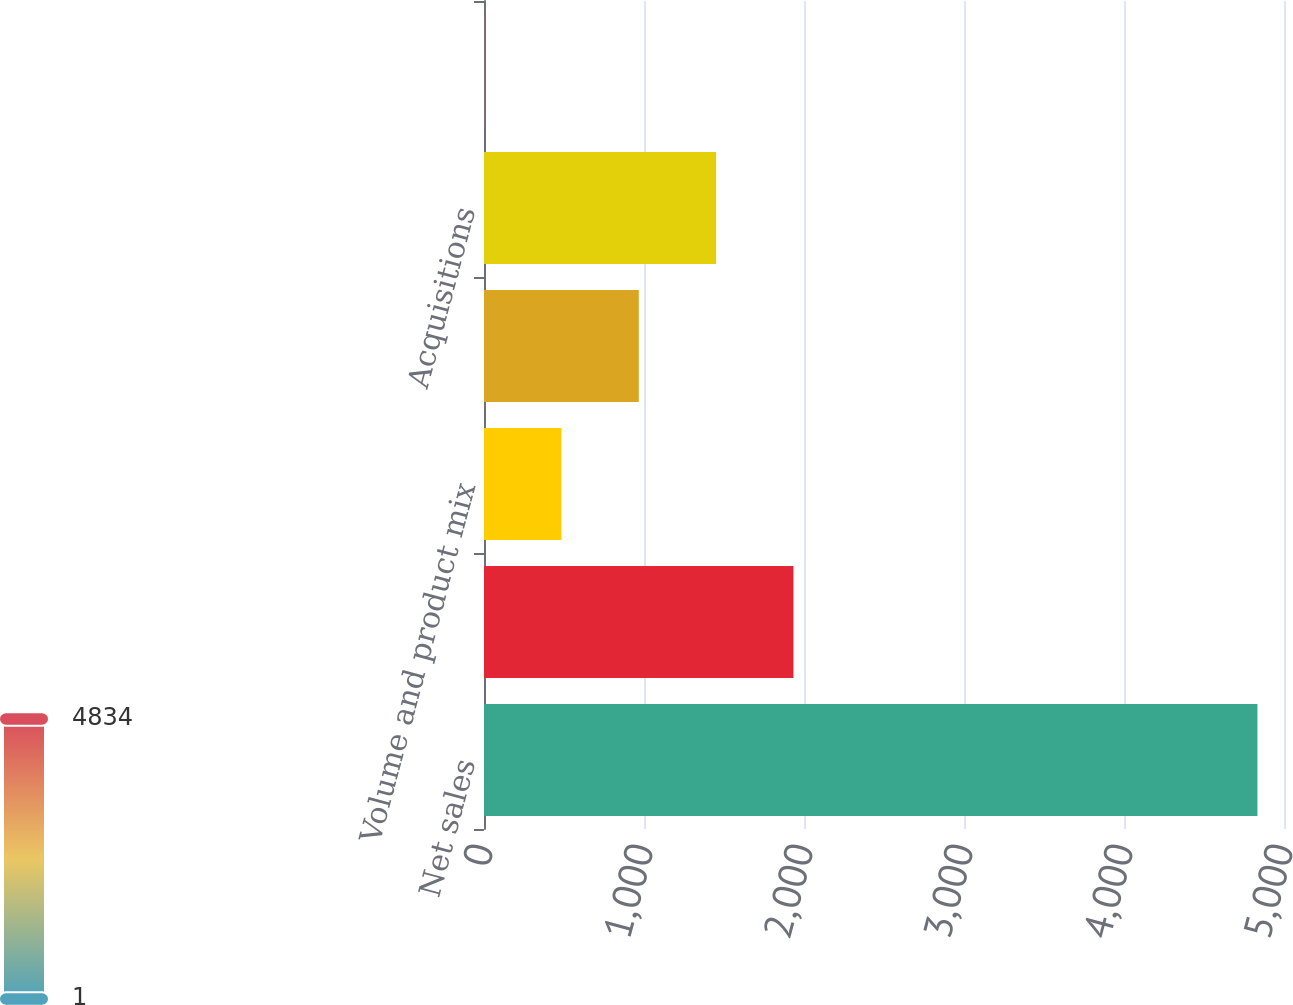Convert chart to OTSL. <chart><loc_0><loc_0><loc_500><loc_500><bar_chart><fcel>Net sales<fcel>Percent growth<fcel>Volume and product mix<fcel>Pricing actions<fcel>Acquisitions<fcel>Foreign exchange<nl><fcel>4834.1<fcel>1934.06<fcel>484.04<fcel>967.38<fcel>1450.72<fcel>0.7<nl></chart> 